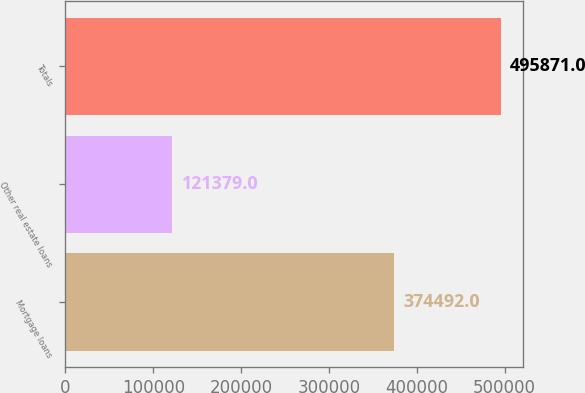Convert chart. <chart><loc_0><loc_0><loc_500><loc_500><bar_chart><fcel>Mortgage loans<fcel>Other real estate loans<fcel>Totals<nl><fcel>374492<fcel>121379<fcel>495871<nl></chart> 